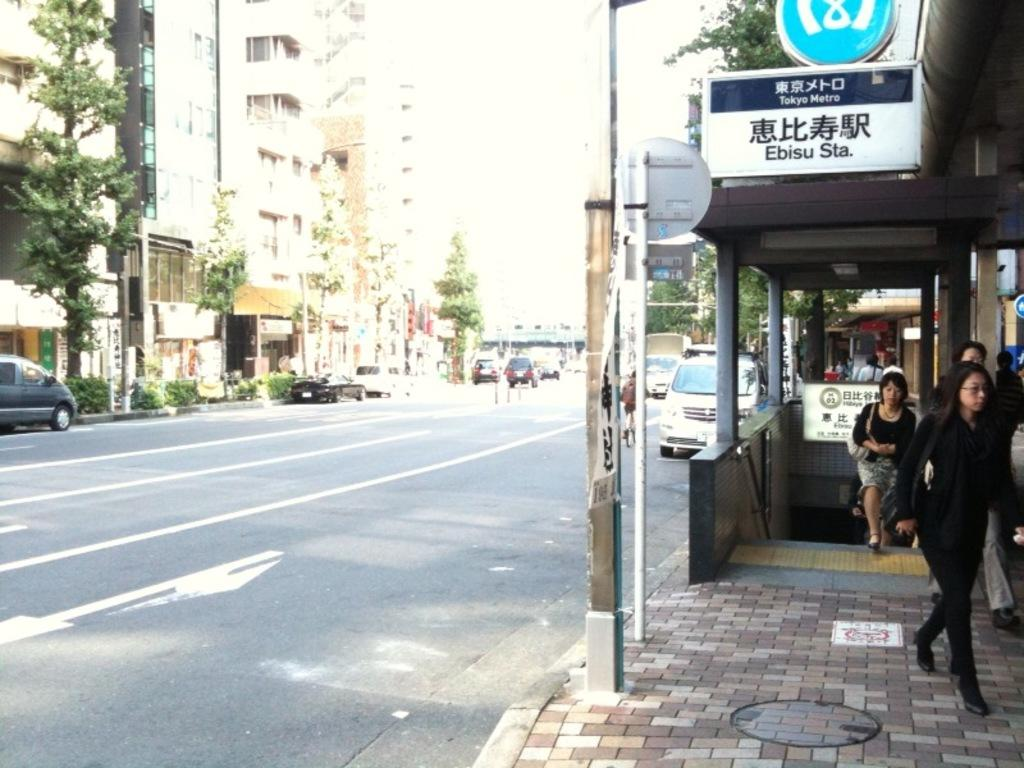<image>
Render a clear and concise summary of the photo. The entrance to the Ebisu subway station has people walking up the stairs. 